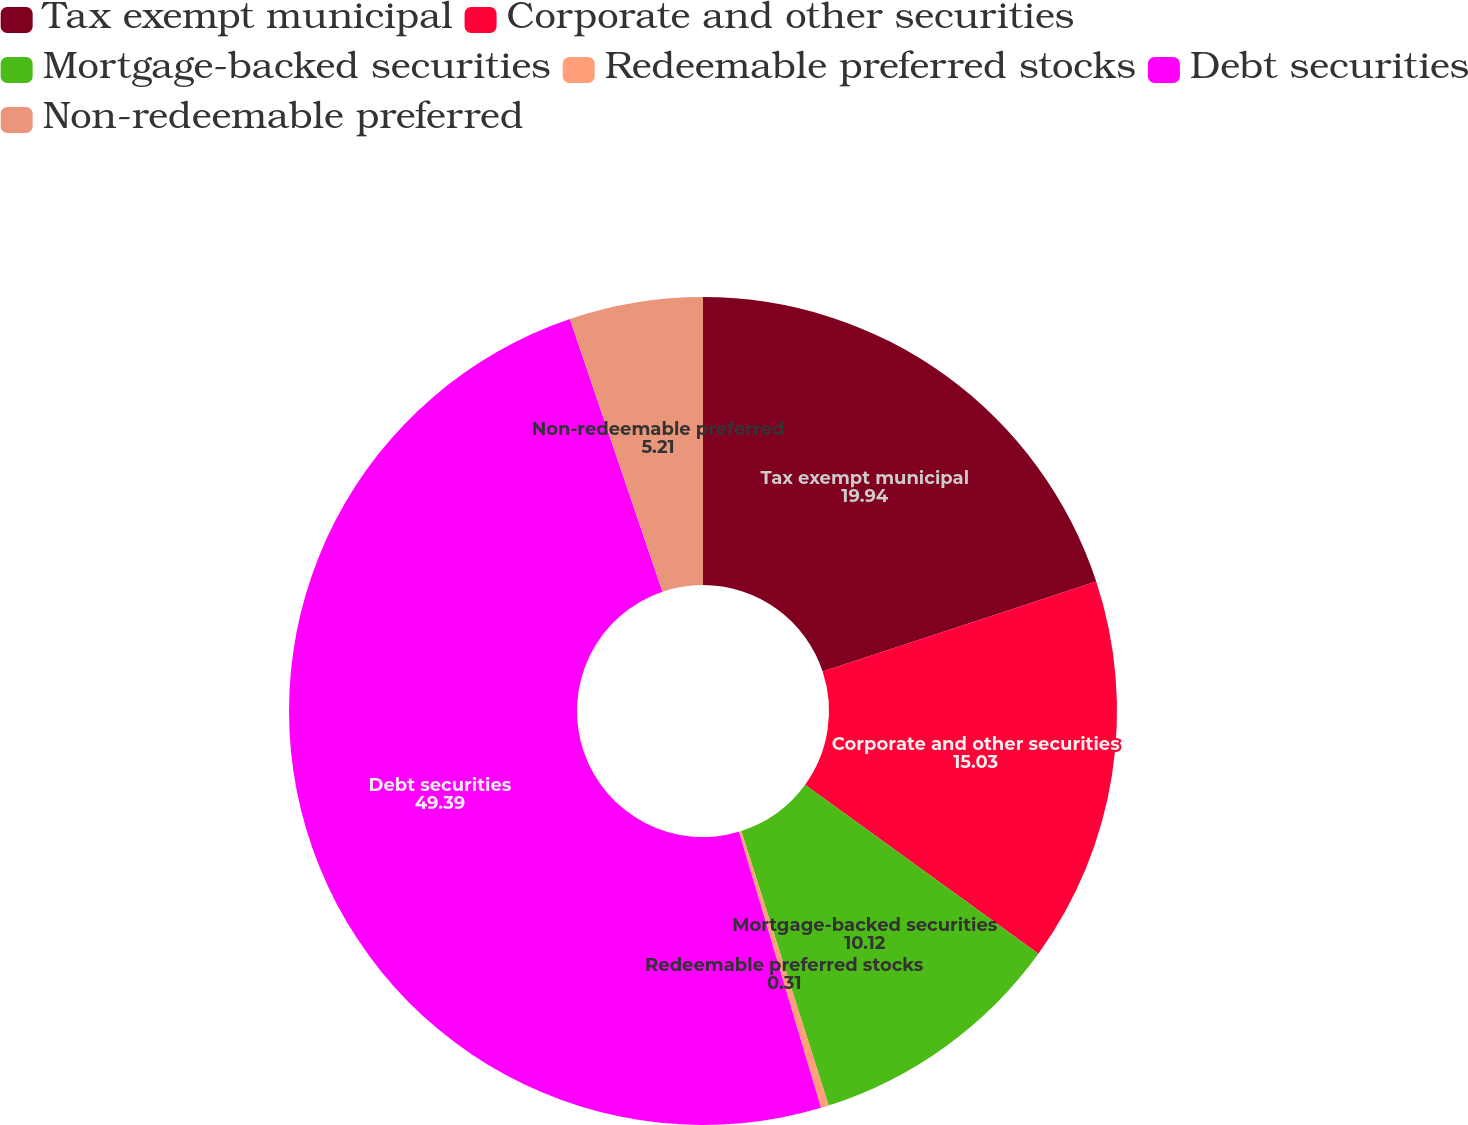Convert chart to OTSL. <chart><loc_0><loc_0><loc_500><loc_500><pie_chart><fcel>Tax exempt municipal<fcel>Corporate and other securities<fcel>Mortgage-backed securities<fcel>Redeemable preferred stocks<fcel>Debt securities<fcel>Non-redeemable preferred<nl><fcel>19.94%<fcel>15.03%<fcel>10.12%<fcel>0.31%<fcel>49.39%<fcel>5.21%<nl></chart> 